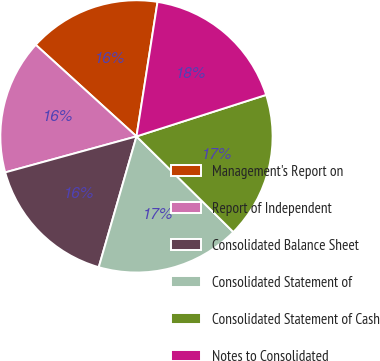Convert chart. <chart><loc_0><loc_0><loc_500><loc_500><pie_chart><fcel>Management's Report on<fcel>Report of Independent<fcel>Consolidated Balance Sheet<fcel>Consolidated Statement of<fcel>Consolidated Statement of Cash<fcel>Notes to Consolidated<nl><fcel>15.73%<fcel>16.0%<fcel>16.27%<fcel>17.07%<fcel>17.33%<fcel>17.6%<nl></chart> 